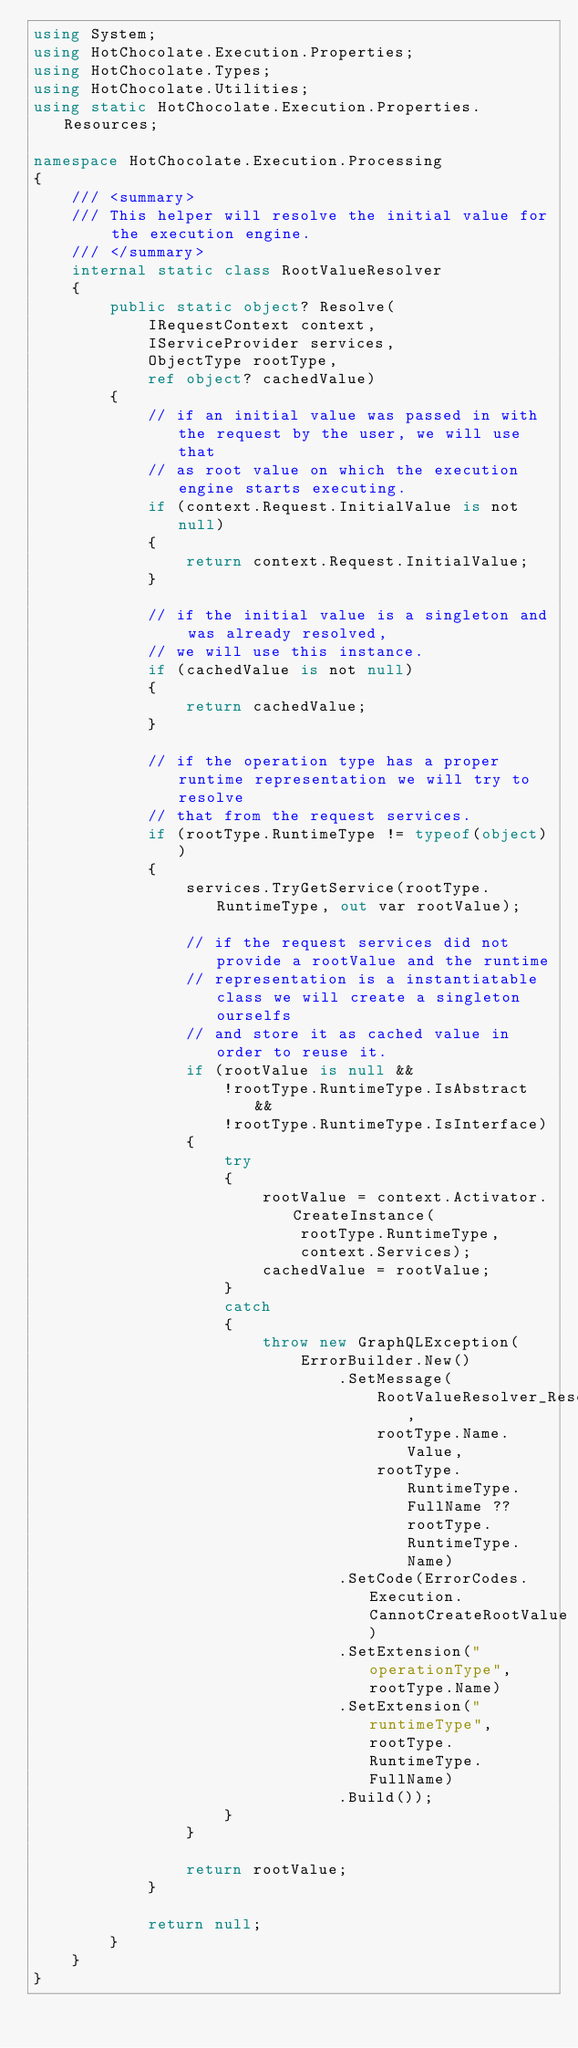Convert code to text. <code><loc_0><loc_0><loc_500><loc_500><_C#_>using System;
using HotChocolate.Execution.Properties;
using HotChocolate.Types;
using HotChocolate.Utilities;
using static HotChocolate.Execution.Properties.Resources;

namespace HotChocolate.Execution.Processing
{
    /// <summary>
    /// This helper will resolve the initial value for the execution engine.
    /// </summary>
    internal static class RootValueResolver
    {
        public static object? Resolve(
            IRequestContext context,
            IServiceProvider services,
            ObjectType rootType,
            ref object? cachedValue)
        {
            // if an initial value was passed in with the request by the user, we will use that
            // as root value on which the execution engine starts executing.
            if (context.Request.InitialValue is not null)
            {
                return context.Request.InitialValue;
            }

            // if the initial value is a singleton and was already resolved,
            // we will use this instance.
            if (cachedValue is not null)
            {
                return cachedValue;
            }

            // if the operation type has a proper runtime representation we will try to resolve
            // that from the request services.
            if (rootType.RuntimeType != typeof(object))
            {
                services.TryGetService(rootType.RuntimeType, out var rootValue);

                // if the request services did not provide a rootValue and the runtime
                // representation is a instantiatable class we will create a singleton ourselfs
                // and store it as cached value in order to reuse it.
                if (rootValue is null &&
                    !rootType.RuntimeType.IsAbstract &&
                    !rootType.RuntimeType.IsInterface)
                {
                    try
                    {
                        rootValue = context.Activator.CreateInstance(
                            rootType.RuntimeType,
                            context.Services);
                        cachedValue = rootValue;
                    }
                    catch
                    {
                        throw new GraphQLException(
                            ErrorBuilder.New()
                                .SetMessage(
                                    RootValueResolver_Resolve_CannotCreateInstance,
                                    rootType.Name.Value,
                                    rootType.RuntimeType.FullName ?? rootType.RuntimeType.Name)
                                .SetCode(ErrorCodes.Execution.CannotCreateRootValue)
                                .SetExtension("operationType", rootType.Name)
                                .SetExtension("runtimeType", rootType.RuntimeType.FullName)
                                .Build());
                    }
                }

                return rootValue;
            }

            return null;
        }
    }
}
</code> 